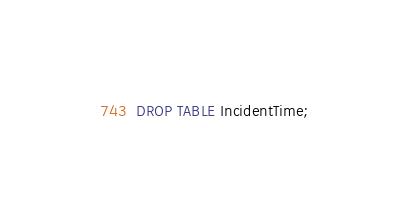Convert code to text. <code><loc_0><loc_0><loc_500><loc_500><_SQL_>DROP TABLE IncidentTime;
</code> 